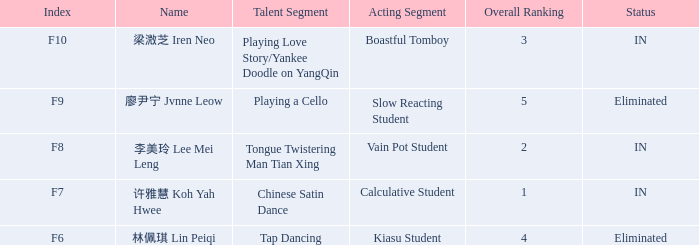Calculate the overall ranking sum for every event with an f10 index. 3.0. 